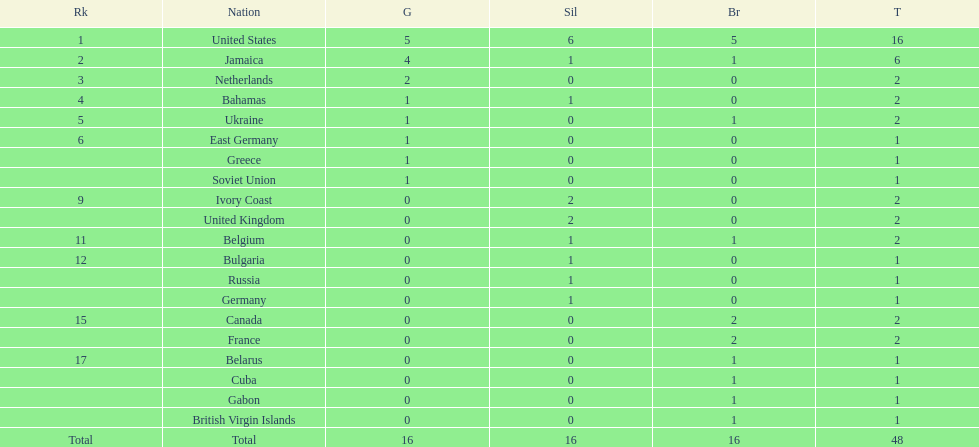What number of nations received 1 medal? 10. 